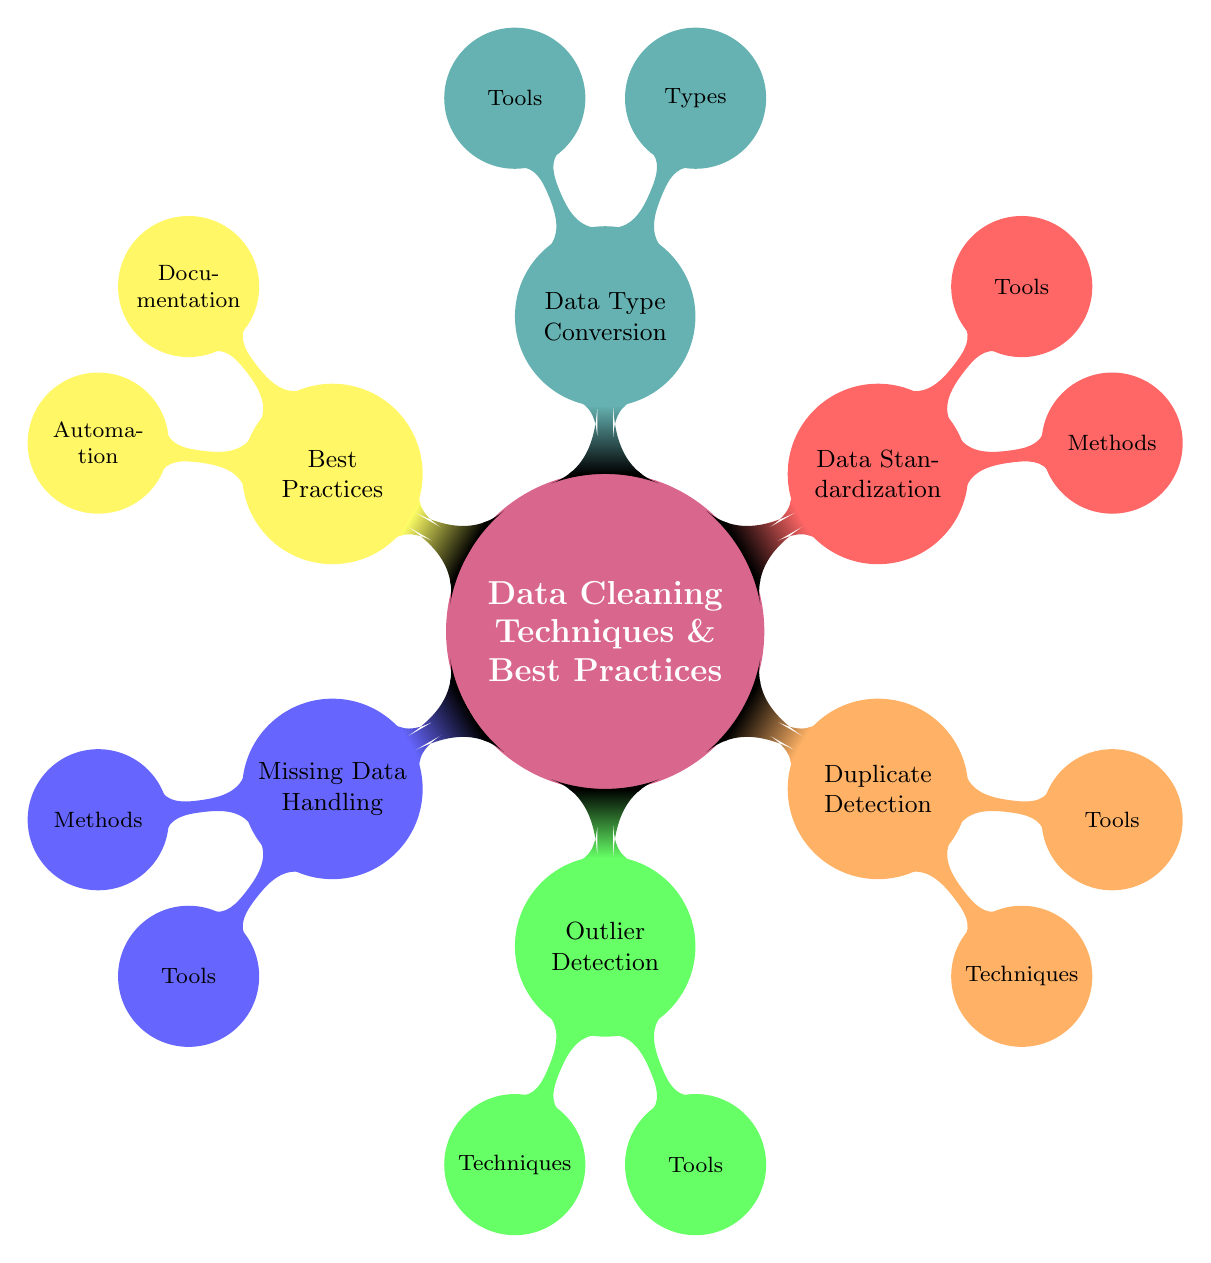What are the two main categories under Best Practices? The diagram lists two categories under Best Practices: Documentation and Automation, which are represented as child nodes under the Best Practices concept node.
Answer: Documentation and Automation How many major data cleaning techniques are listed in the diagram? The diagram presents six major techniques, which are represented as child nodes under the main concept node of Data Cleaning Techniques & Best Practices.
Answer: Six What tools are associated with Missing Data Handling? The diagram specifies two tools associated with Missing Data Handling, which are displayed under the Tools node of this category.
Answer: pandas and NumPy Which method is used for Outlier Detection according to the diagram? The diagram shows two techniques for Outlier Detection: Z-Score and IQR Method, which are children of the Outlier Detection node.
Answer: Z-Score and IQR Method What is the relationship between Data Standardization and its Methods? The relationship is that Data Standardization has Methods as its child nodes, which include Scaling and Normalization, indicating the specific methods used for standardizing data.
Answer: Methods are Scaling and Normalization How does Duplicate Detection relate to its Techniques? Duplicate Detection has two main Techniques, specifically Exact Match and Fuzzy Matching, shown as child nodes under the Duplicate Detection node, indicating the approaches for identifying duplicates.
Answer: Exact Match and Fuzzy Matching What are the types of Data Type Conversion mentioned in the diagram? The Types under the Data Type Conversion category include String to Numeric and Datetime Conversion, which are displayed as child nodes indicating the different types of conversions performed.
Answer: String to Numeric and Datetime Conversion Which tool is associated with Data Standardization? The diagram lists two tools under Data Standardization, where scikit-learn is prominently displayed as one of the tools used in the standardization process.
Answer: scikit-learn What are the two methods listed under Missing Data Handling? Under the Missing Data Handling category, two methods are specified as Imputation and Deletion, displayed as child nodes indicating the strategies for addressing missing data.
Answer: Imputation and Deletion 